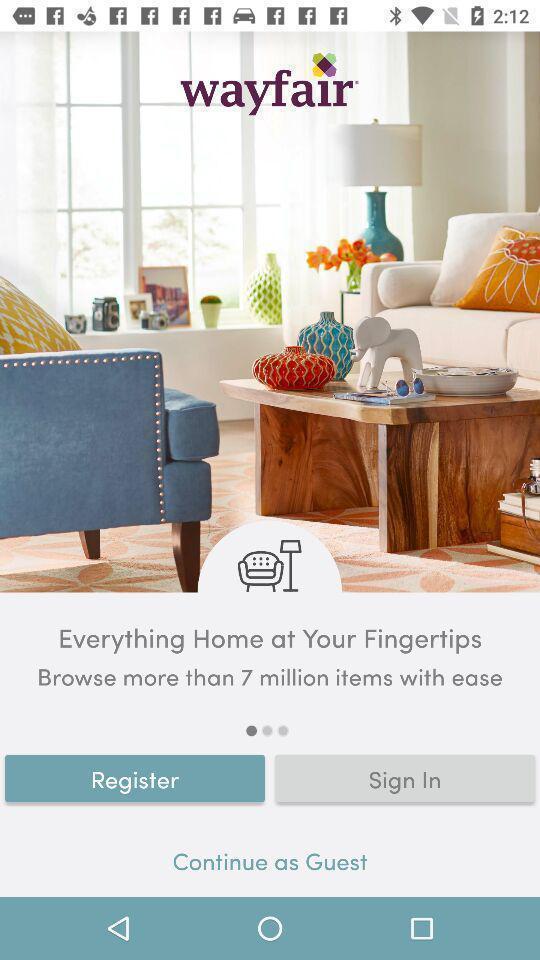What details can you identify in this image? Sign in page of a shopping page. 